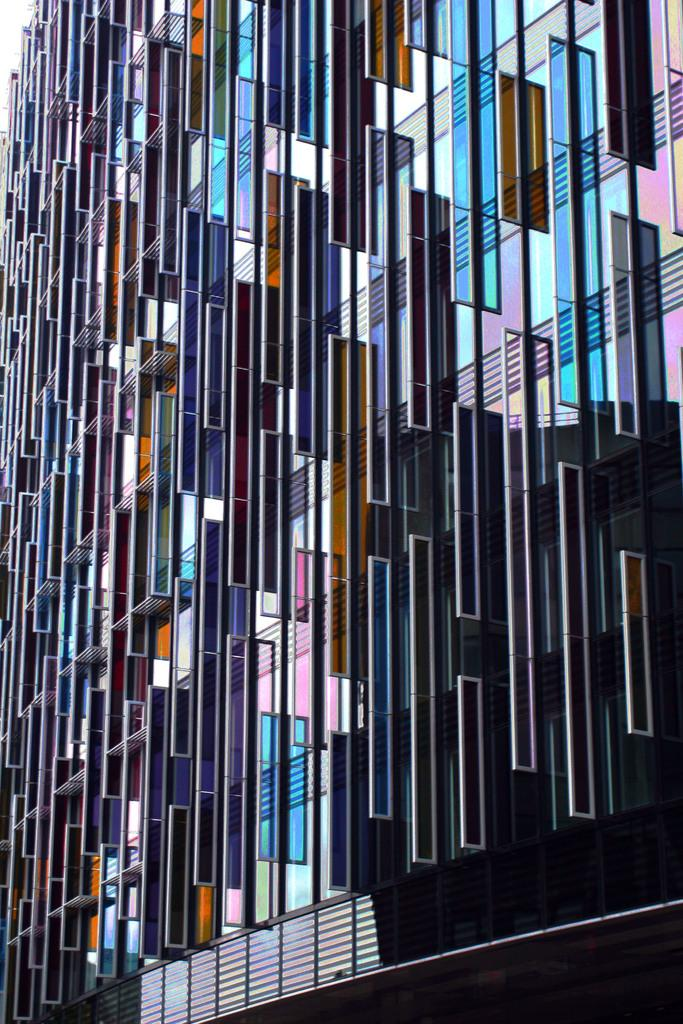What type of objects can be seen in the image? There are different glass frames in the image. Where are the glass frames located? The glass frames are placed on a building. What is the tendency of the moon in the image? There is no moon present in the image, so it is not possible to determine its tendency. 